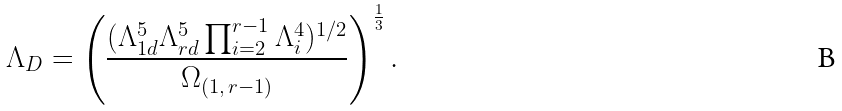<formula> <loc_0><loc_0><loc_500><loc_500>\Lambda _ { D } = \left ( \frac { ( \Lambda _ { 1 d } ^ { 5 } \Lambda _ { r d } ^ { 5 } \prod _ { i = 2 } ^ { r - 1 } \Lambda _ { i } ^ { 4 } ) ^ { 1 / 2 } } { \Omega _ { ( 1 , \, r - 1 ) } } \right ) ^ { \frac { 1 } { 3 } } .</formula> 